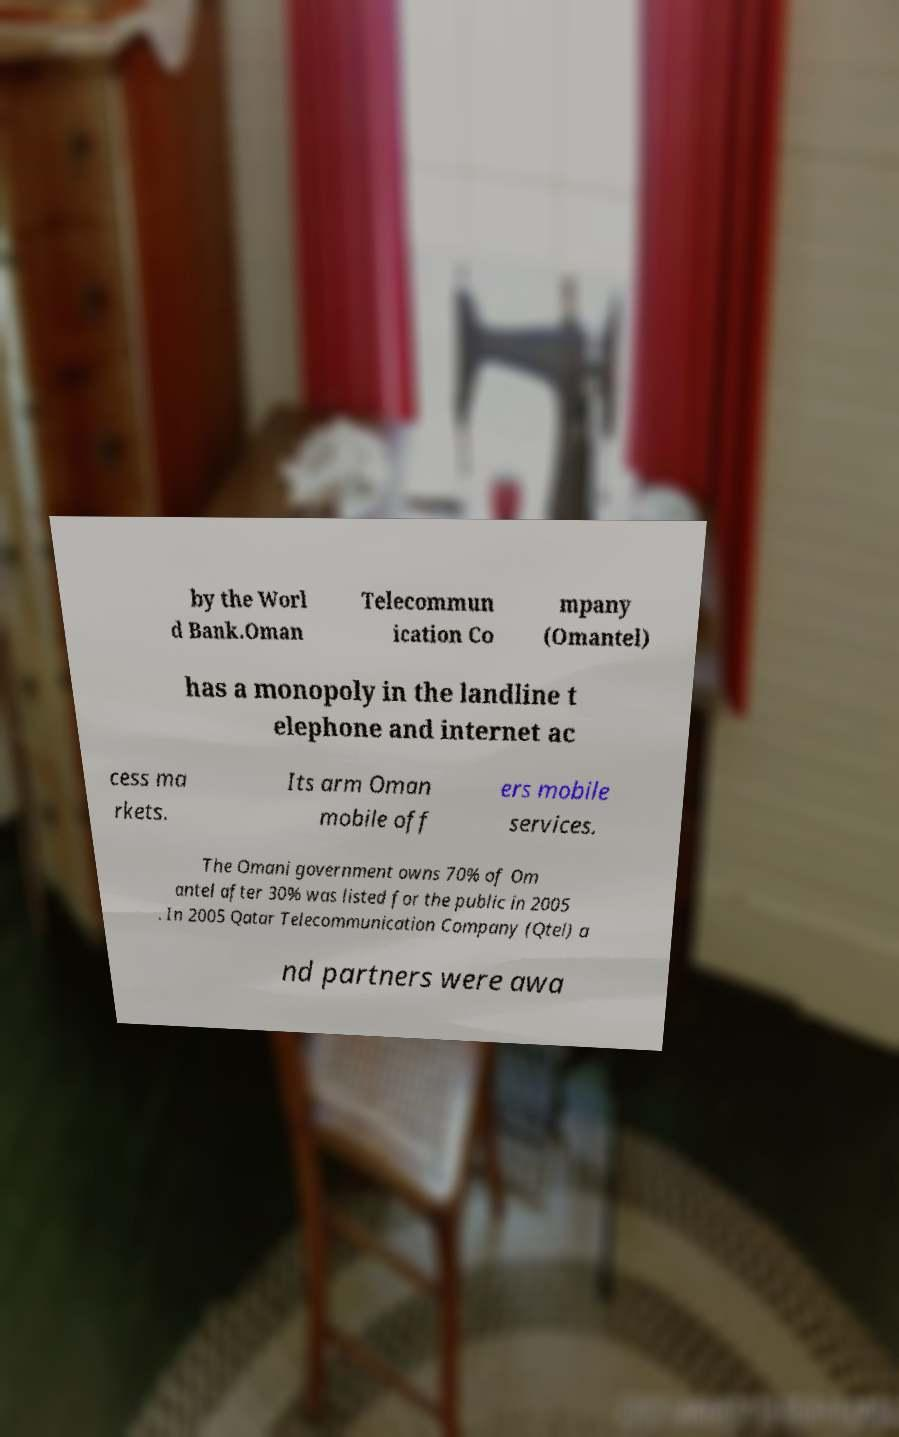Can you accurately transcribe the text from the provided image for me? by the Worl d Bank.Oman Telecommun ication Co mpany (Omantel) has a monopoly in the landline t elephone and internet ac cess ma rkets. Its arm Oman mobile off ers mobile services. The Omani government owns 70% of Om antel after 30% was listed for the public in 2005 . In 2005 Qatar Telecommunication Company (Qtel) a nd partners were awa 